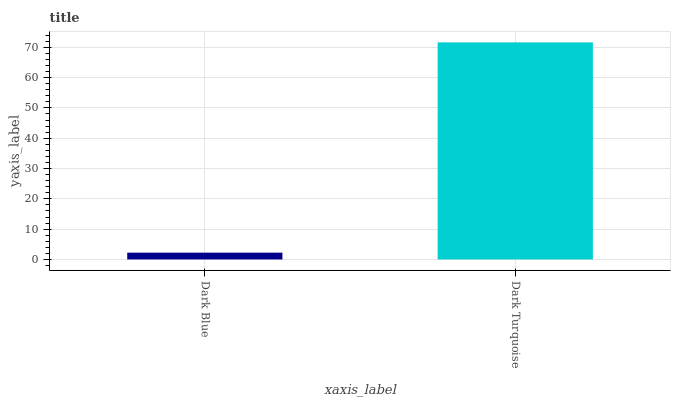Is Dark Blue the minimum?
Answer yes or no. Yes. Is Dark Turquoise the maximum?
Answer yes or no. Yes. Is Dark Turquoise the minimum?
Answer yes or no. No. Is Dark Turquoise greater than Dark Blue?
Answer yes or no. Yes. Is Dark Blue less than Dark Turquoise?
Answer yes or no. Yes. Is Dark Blue greater than Dark Turquoise?
Answer yes or no. No. Is Dark Turquoise less than Dark Blue?
Answer yes or no. No. Is Dark Turquoise the high median?
Answer yes or no. Yes. Is Dark Blue the low median?
Answer yes or no. Yes. Is Dark Blue the high median?
Answer yes or no. No. Is Dark Turquoise the low median?
Answer yes or no. No. 